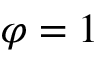<formula> <loc_0><loc_0><loc_500><loc_500>\varphi = 1</formula> 